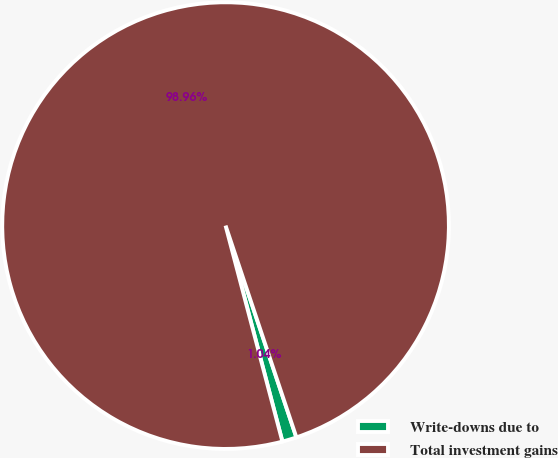Convert chart to OTSL. <chart><loc_0><loc_0><loc_500><loc_500><pie_chart><fcel>Write-downs due to<fcel>Total investment gains<nl><fcel>1.04%<fcel>98.96%<nl></chart> 